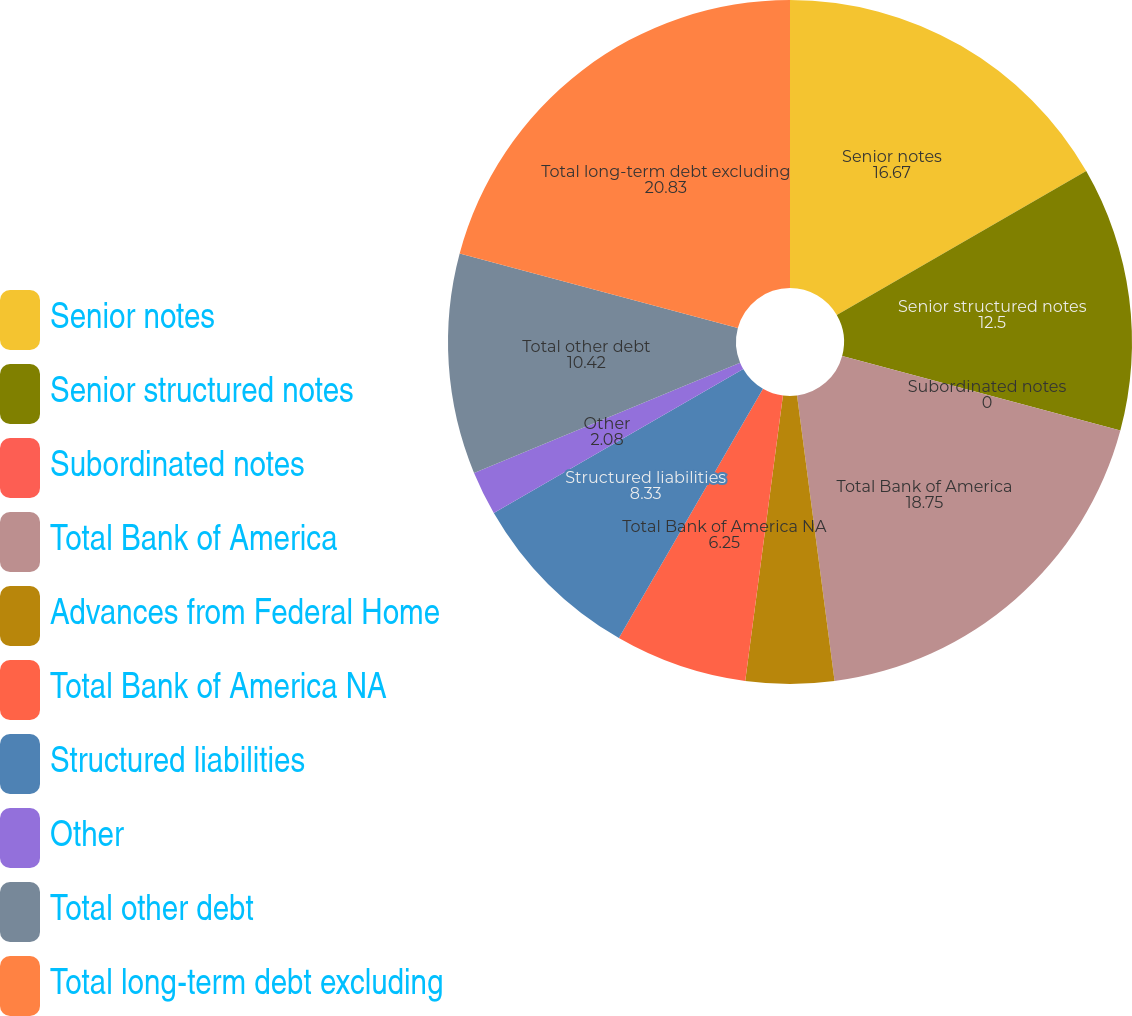Convert chart to OTSL. <chart><loc_0><loc_0><loc_500><loc_500><pie_chart><fcel>Senior notes<fcel>Senior structured notes<fcel>Subordinated notes<fcel>Total Bank of America<fcel>Advances from Federal Home<fcel>Total Bank of America NA<fcel>Structured liabilities<fcel>Other<fcel>Total other debt<fcel>Total long-term debt excluding<nl><fcel>16.67%<fcel>12.5%<fcel>0.0%<fcel>18.75%<fcel>4.17%<fcel>6.25%<fcel>8.33%<fcel>2.08%<fcel>10.42%<fcel>20.83%<nl></chart> 